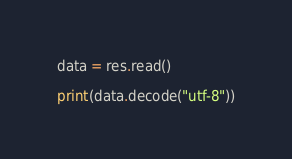Convert code to text. <code><loc_0><loc_0><loc_500><loc_500><_Python_>data = res.read()

print(data.decode("utf-8"))
</code> 